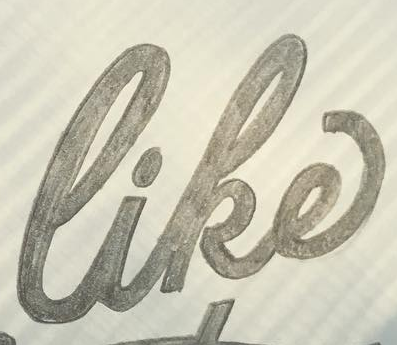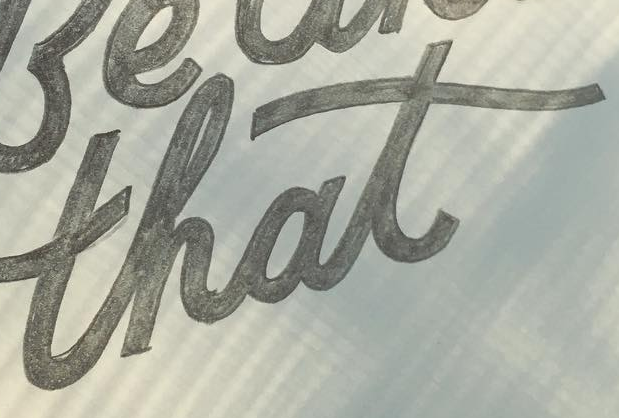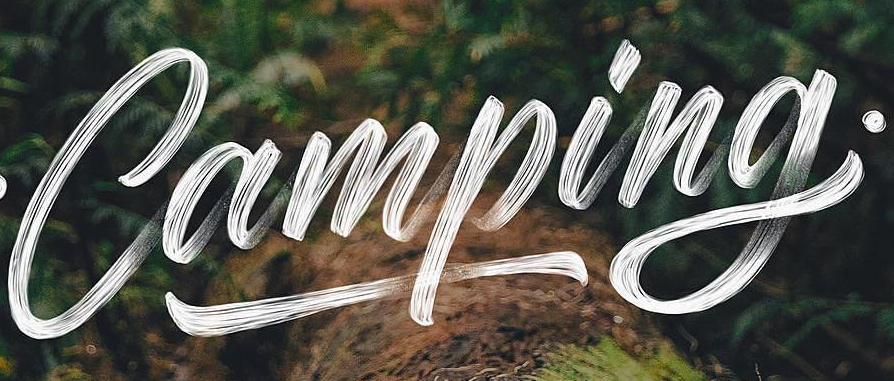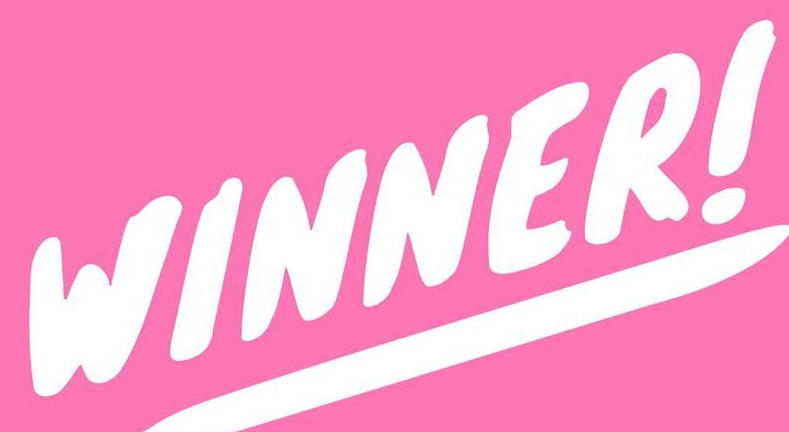What words are shown in these images in order, separated by a semicolon? like; that; Camping; WINNER! 